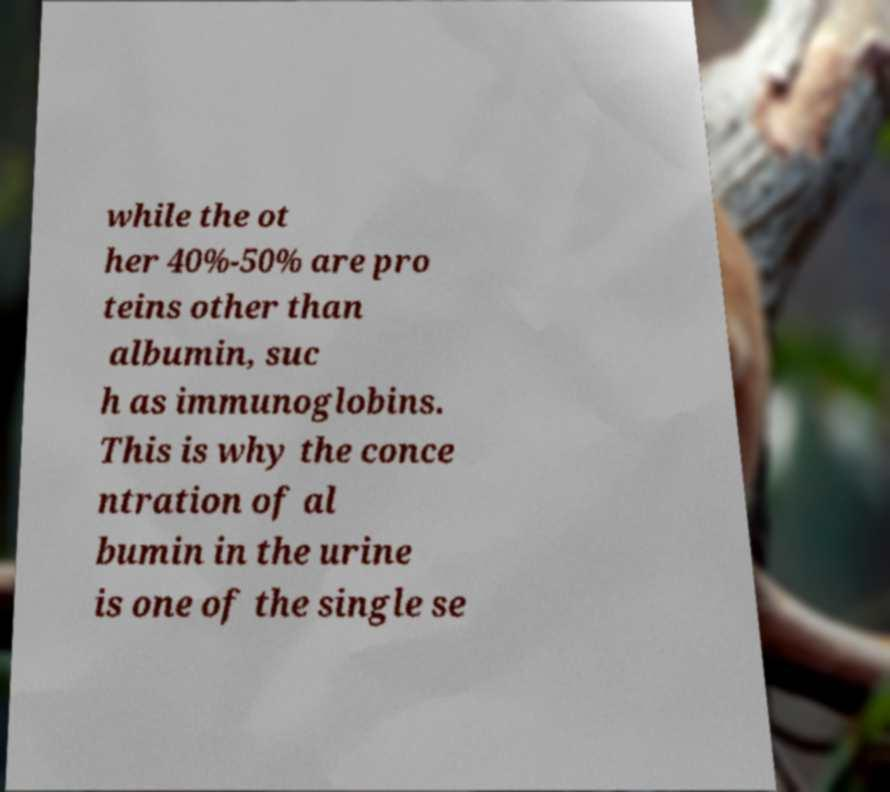What messages or text are displayed in this image? I need them in a readable, typed format. while the ot her 40%-50% are pro teins other than albumin, suc h as immunoglobins. This is why the conce ntration of al bumin in the urine is one of the single se 